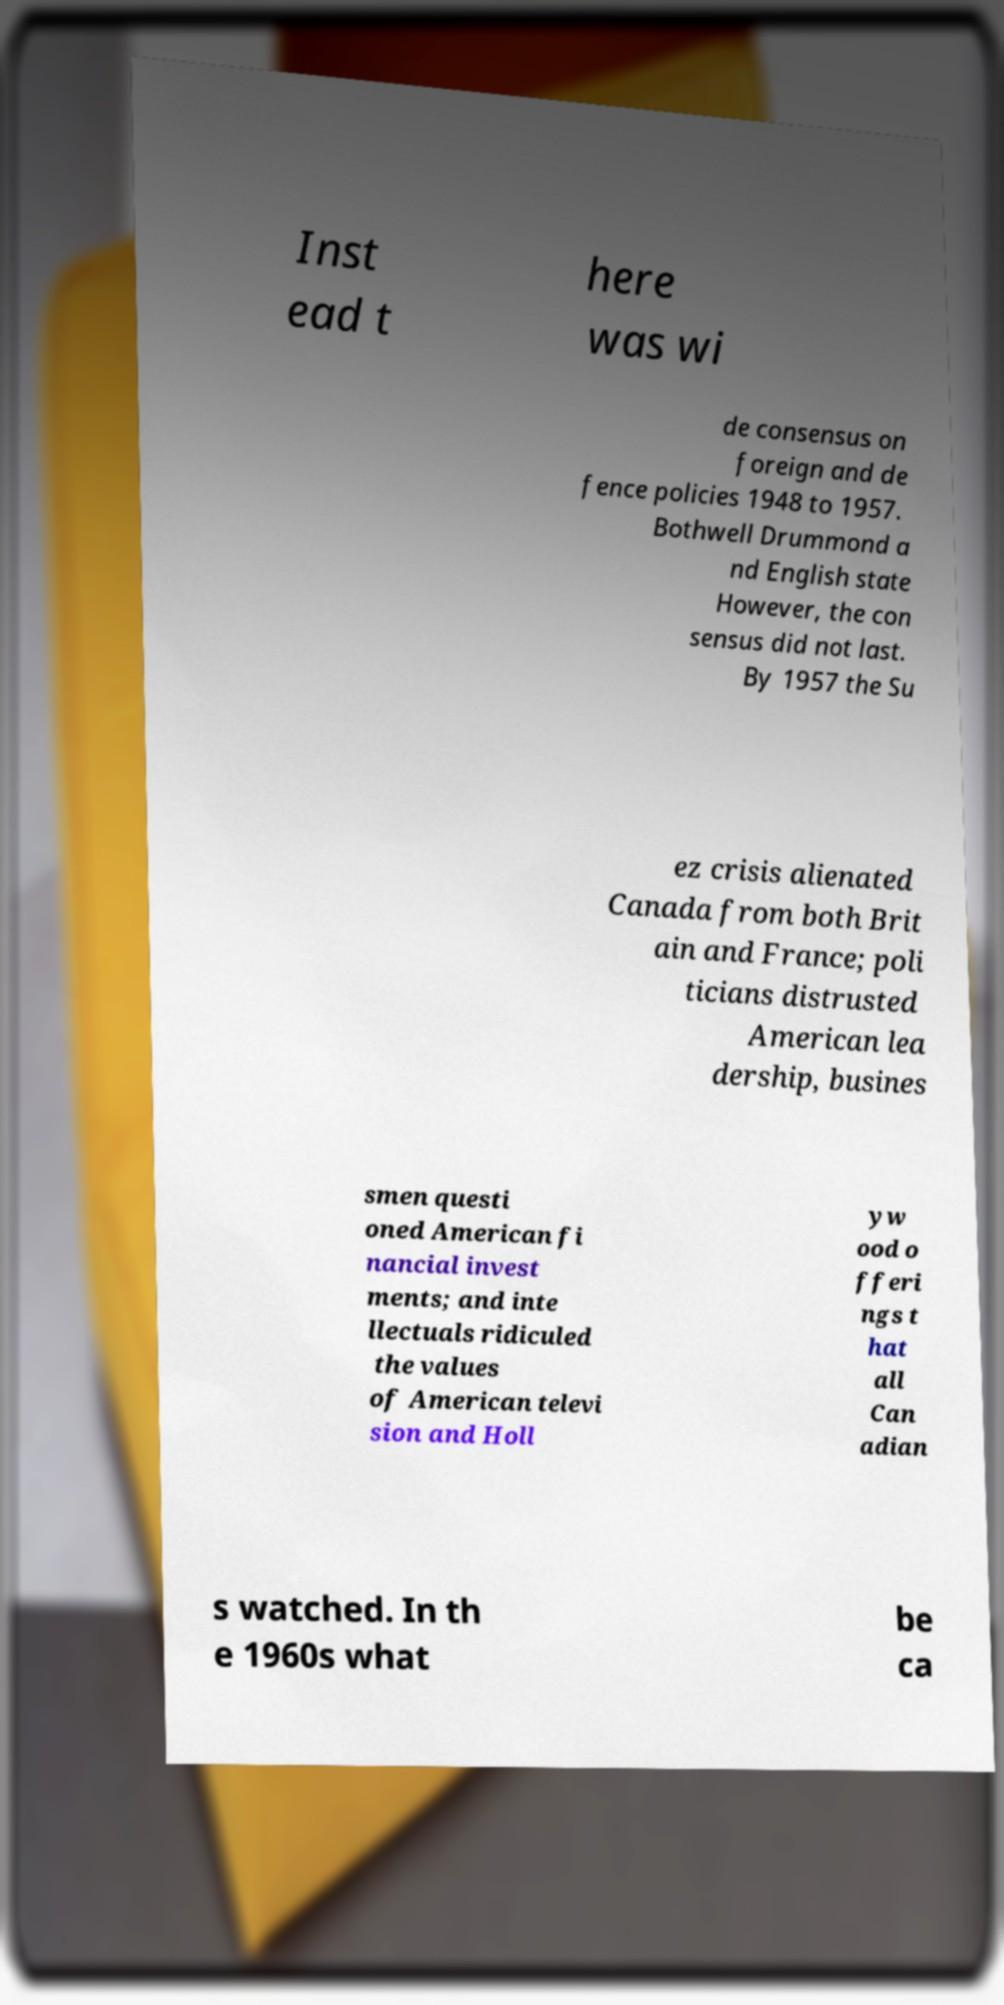Please identify and transcribe the text found in this image. Inst ead t here was wi de consensus on foreign and de fence policies 1948 to 1957. Bothwell Drummond a nd English state However, the con sensus did not last. By 1957 the Su ez crisis alienated Canada from both Brit ain and France; poli ticians distrusted American lea dership, busines smen questi oned American fi nancial invest ments; and inte llectuals ridiculed the values of American televi sion and Holl yw ood o fferi ngs t hat all Can adian s watched. In th e 1960s what be ca 